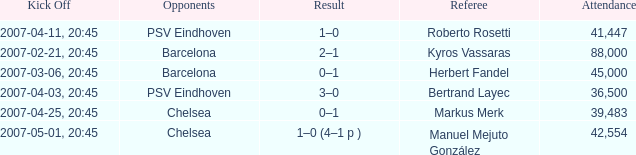Could you parse the entire table? {'header': ['Kick Off', 'Opponents', 'Result', 'Referee', 'Attendance'], 'rows': [['2007-04-11, 20:45', 'PSV Eindhoven', '1–0', 'Roberto Rosetti', '41,447'], ['2007-02-21, 20:45', 'Barcelona', '2–1', 'Kyros Vassaras', '88,000'], ['2007-03-06, 20:45', 'Barcelona', '0–1', 'Herbert Fandel', '45,000'], ['2007-04-03, 20:45', 'PSV Eindhoven', '3–0', 'Bertrand Layec', '36,500'], ['2007-04-25, 20:45', 'Chelsea', '0–1', 'Markus Merk', '39,483'], ['2007-05-01, 20:45', 'Chelsea', '1–0 (4–1 p )', 'Manuel Mejuto González', '42,554']]} WHAT OPPONENT HAD A KICKOFF OF 2007-03-06, 20:45? Barcelona. 